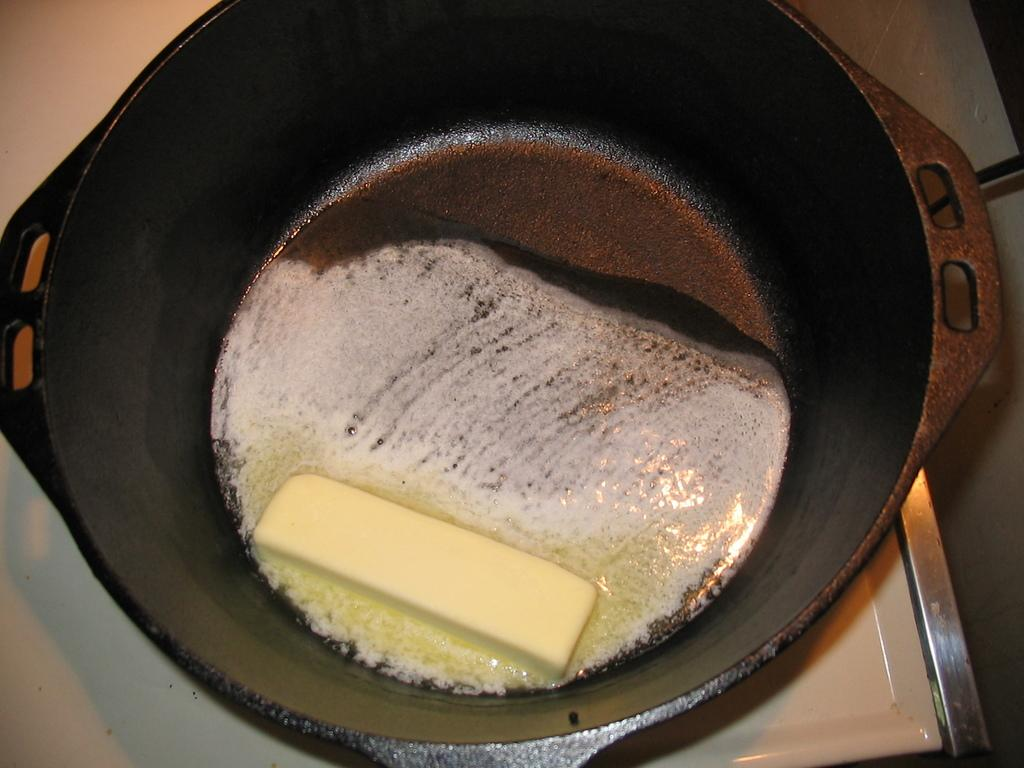What is the main subject in the image? There is butter in the image. How is the butter contained in the image? The butter is in a bowl. What is the color of the bowl containing the butter? The bowl is black in color. What type of bomb is depicted in the image? There is no bomb present in the image; it features butter in a black bowl. What type of powder is being used to make the butter in the image? There is no powder present in the image; it simply shows butter in a black bowl. 